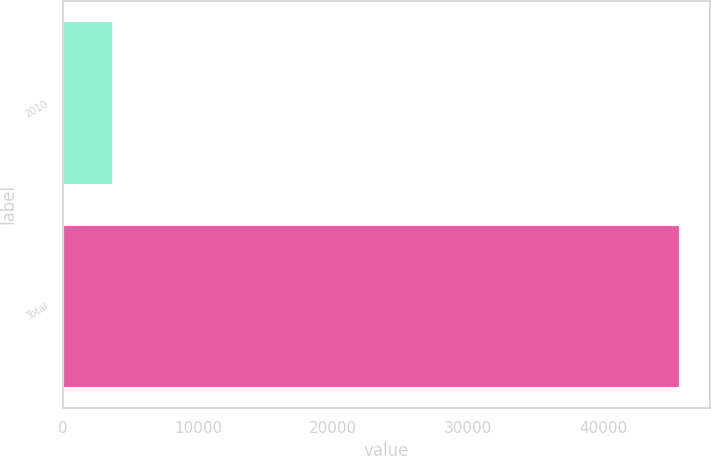Convert chart. <chart><loc_0><loc_0><loc_500><loc_500><bar_chart><fcel>2010<fcel>Total<nl><fcel>3642<fcel>45610<nl></chart> 